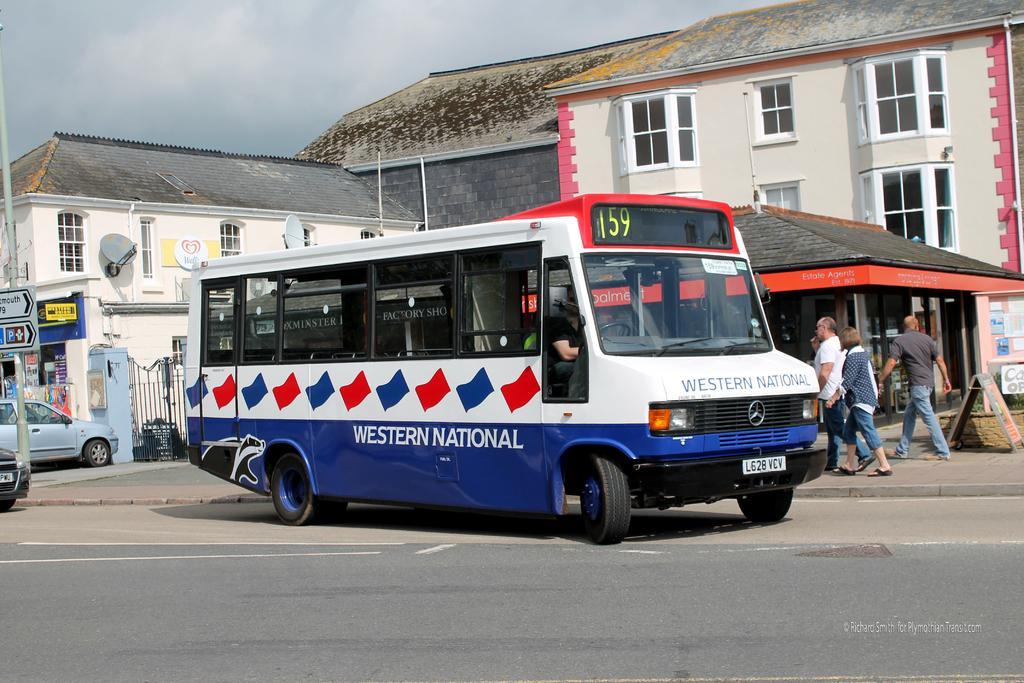In one or two sentences, can you explain what this image depicts? In this image in the foreground there is one bus in that bus there is one person who is sitting and driving, and in the background there are some houses and some stores and boards. On the left side there are some vehicles and pole some boards, on the right side there are some people who are walking. At the bottom there is a road. 